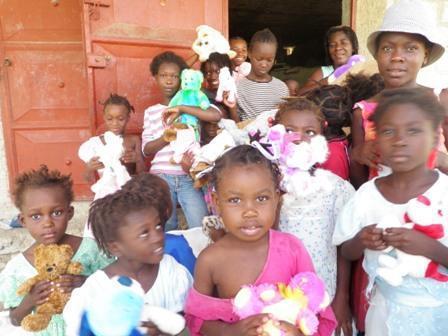How many girls wearing hats?
Give a very brief answer. 1. How many men in picture?
Give a very brief answer. 0. 